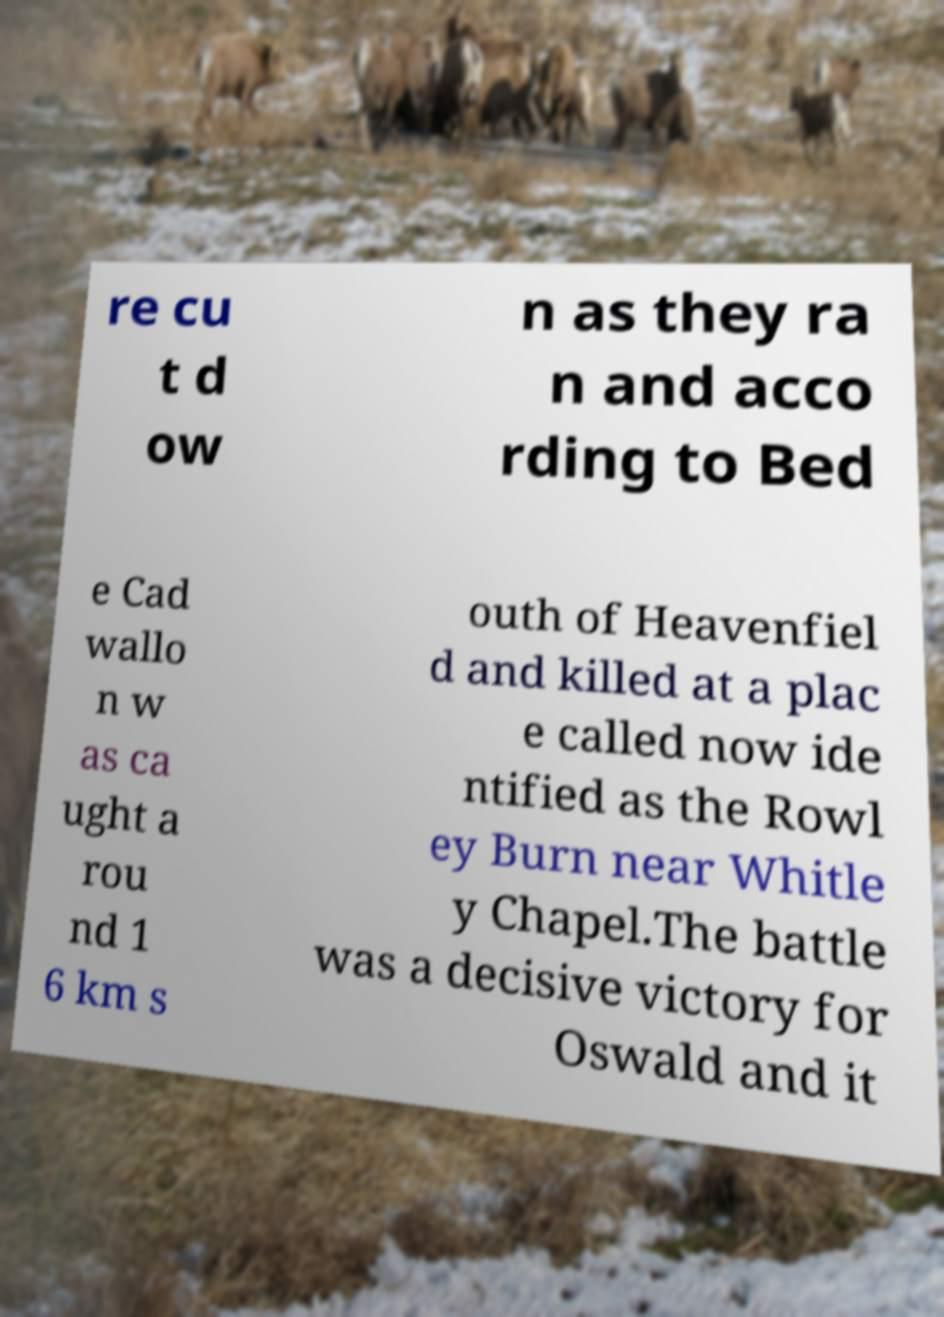Can you accurately transcribe the text from the provided image for me? re cu t d ow n as they ra n and acco rding to Bed e Cad wallo n w as ca ught a rou nd 1 6 km s outh of Heavenfiel d and killed at a plac e called now ide ntified as the Rowl ey Burn near Whitle y Chapel.The battle was a decisive victory for Oswald and it 